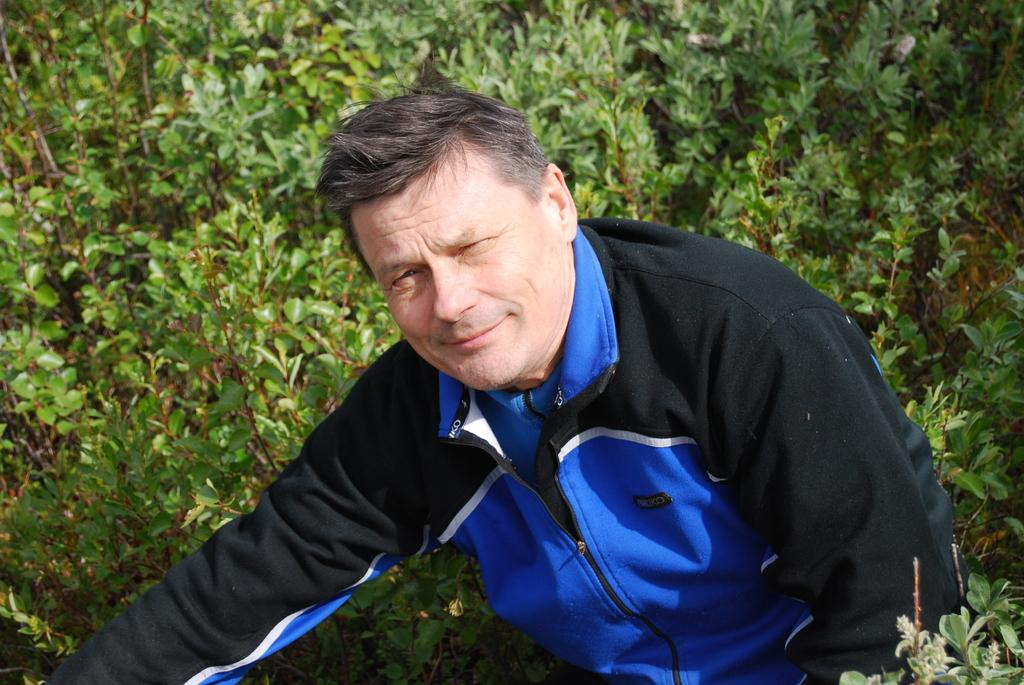Who is present in the image? There is a man in the image. What is the man wearing? The man is wearing a blue and black jacket. What can be seen in the background of the image? There are plants in the background of the image. What type of behavior can be observed in the man while he is exchanging money on the slope? There is no mention of money exchange or a slope in the image, and the man's behavior cannot be determined from the provided facts. 